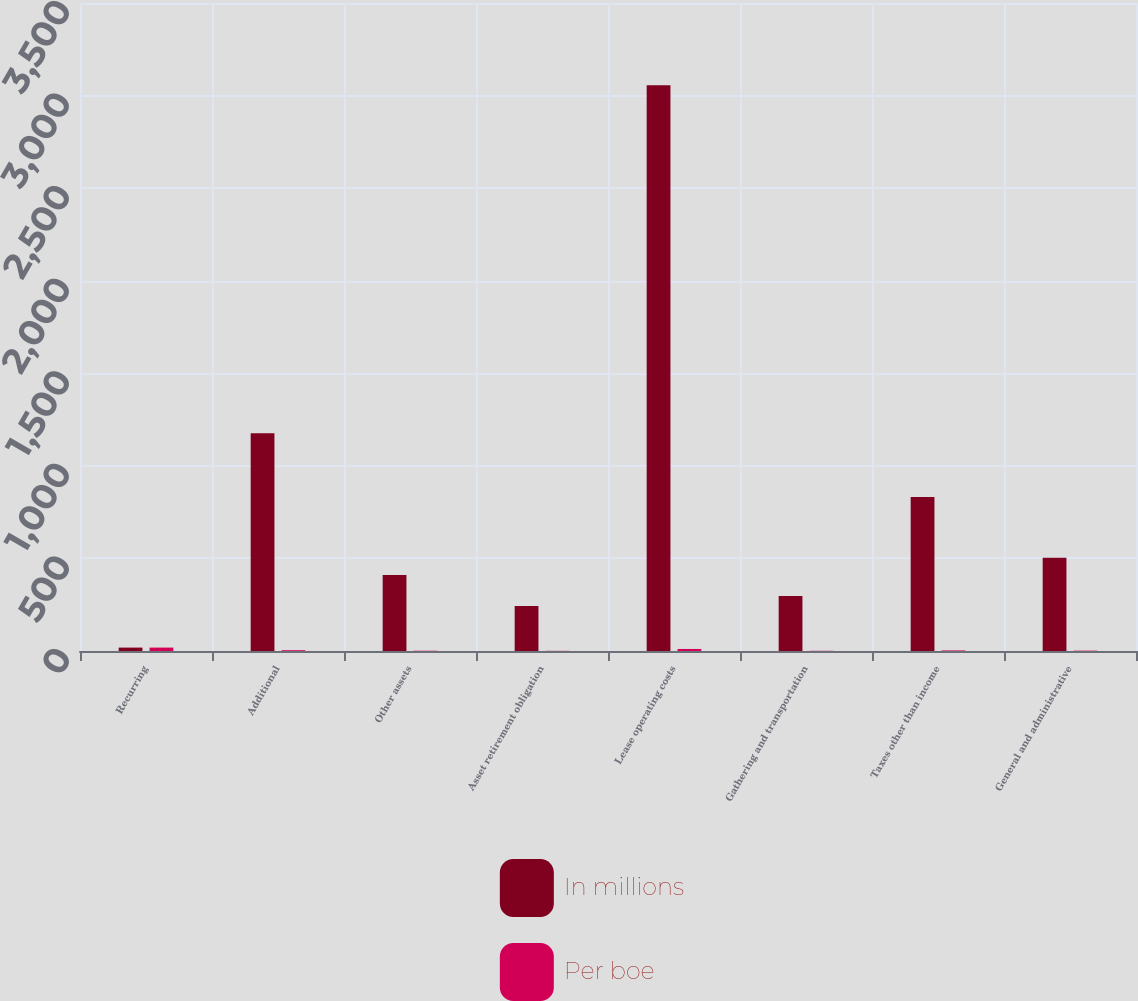Convert chart to OTSL. <chart><loc_0><loc_0><loc_500><loc_500><stacked_bar_chart><ecel><fcel>Recurring<fcel>Additional<fcel>Other assets<fcel>Asset retirement obligation<fcel>Lease operating costs<fcel>Gathering and transportation<fcel>Taxes other than income<fcel>General and administrative<nl><fcel>In millions<fcel>18.42<fcel>1176<fcel>410<fcel>243<fcel>3056<fcel>297<fcel>832<fcel>503<nl><fcel>Per boe<fcel>18.42<fcel>4.24<fcel>1.47<fcel>0.88<fcel>11<fcel>1.06<fcel>3<fcel>1.81<nl></chart> 